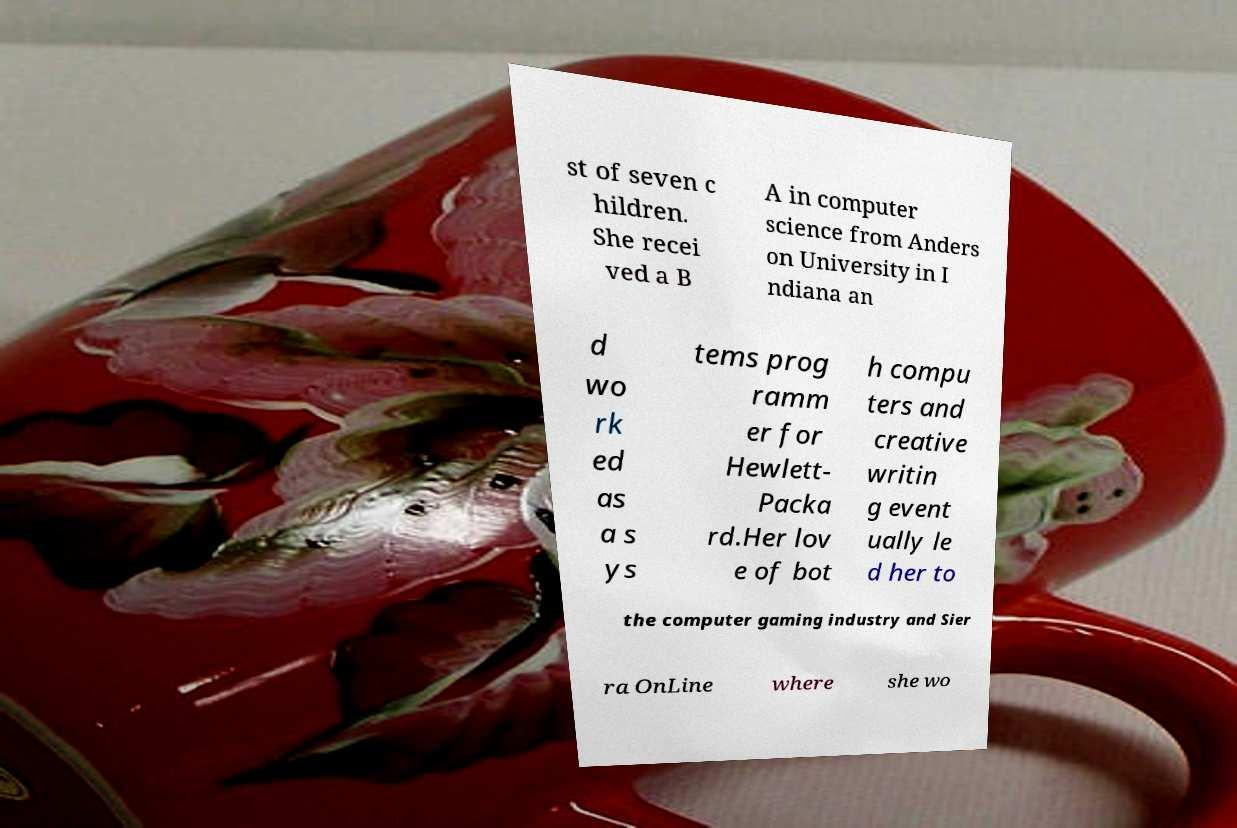I need the written content from this picture converted into text. Can you do that? st of seven c hildren. She recei ved a B A in computer science from Anders on University in I ndiana an d wo rk ed as a s ys tems prog ramm er for Hewlett- Packa rd.Her lov e of bot h compu ters and creative writin g event ually le d her to the computer gaming industry and Sier ra OnLine where she wo 